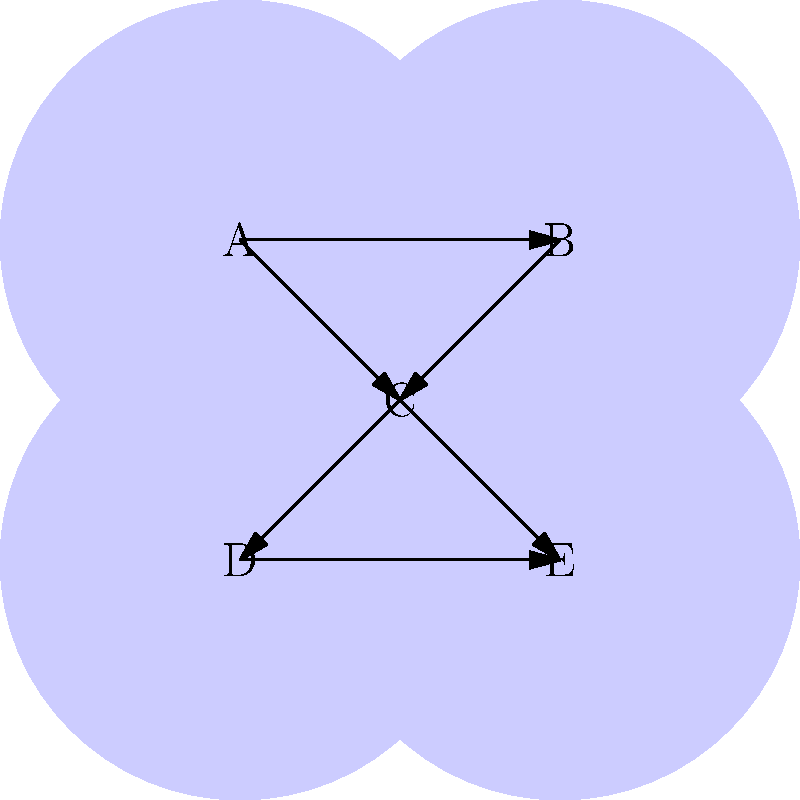In the network diagram of blog topics, which node represents the most interconnected topic that could be considered a central hub for clustering related content? To determine the most interconnected node that could serve as a central hub for clustering, we need to analyze the connections of each node:

1. Node A: Has 2 outgoing connections (to B and C)
2. Node B: Has 1 outgoing connection (to C)
3. Node C: Has 3 connections (2 incoming from A and B, 2 outgoing to D and E)
4. Node D: Has 1 outgoing connection (to E)
5. Node E: Has no outgoing connections

Step 1: Count the total connections for each node:
- A: 2 connections
- B: 2 connections
- C: 4 connections
- D: 2 connections
- E: 2 connections

Step 2: Identify the node with the most connections:
Node C has the highest number of connections (4), making it the most interconnected.

Step 3: Analyze the position of Node C:
Node C is connected to all other nodes either directly or indirectly, serving as a bridge between the upper (A and B) and lower (D and E) parts of the network.

Step 4: Consider the implications for clustering:
As a public relations professional, identifying Node C as the central hub allows for efficient organization of blog topics. Content related to this central topic can be easily linked to other topics, facilitating the creation of thematic clusters and improving navigation for industry professionals seeking information.
Answer: C 